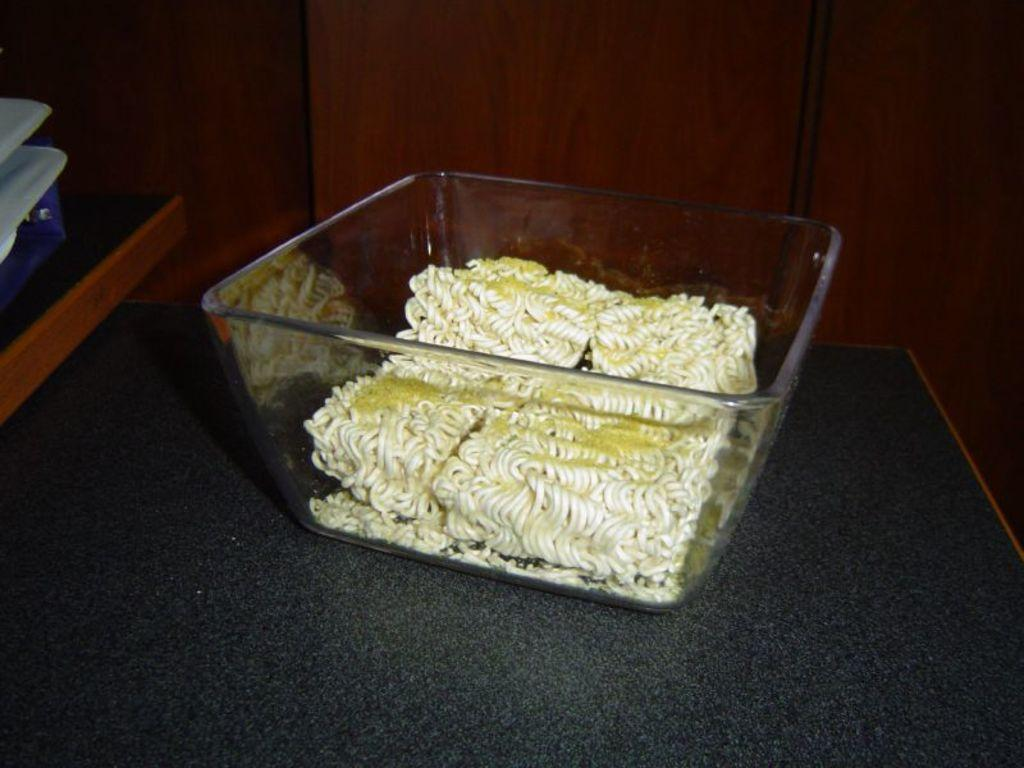What is the main piece of furniture in the image? There is a table in the image. What is placed on the table? There is a bowl on the table. What is inside the bowl? The bowl contains noodles. What type of stocking can be seen hanging from the table in the image? There is no stocking present in the image; it only features a table, a bowl, and noodles. 